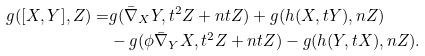<formula> <loc_0><loc_0><loc_500><loc_500>g ( [ X , Y ] , Z ) = & g ( \bar { \nabla } _ { X } Y , t ^ { 2 } Z + n t Z ) + g ( h ( X , t Y ) , n Z ) \\ & - g ( \phi \bar { \nabla } _ { Y } { X } , t ^ { 2 } Z + n t Z ) - g ( h ( Y , t X ) , n Z ) .</formula> 